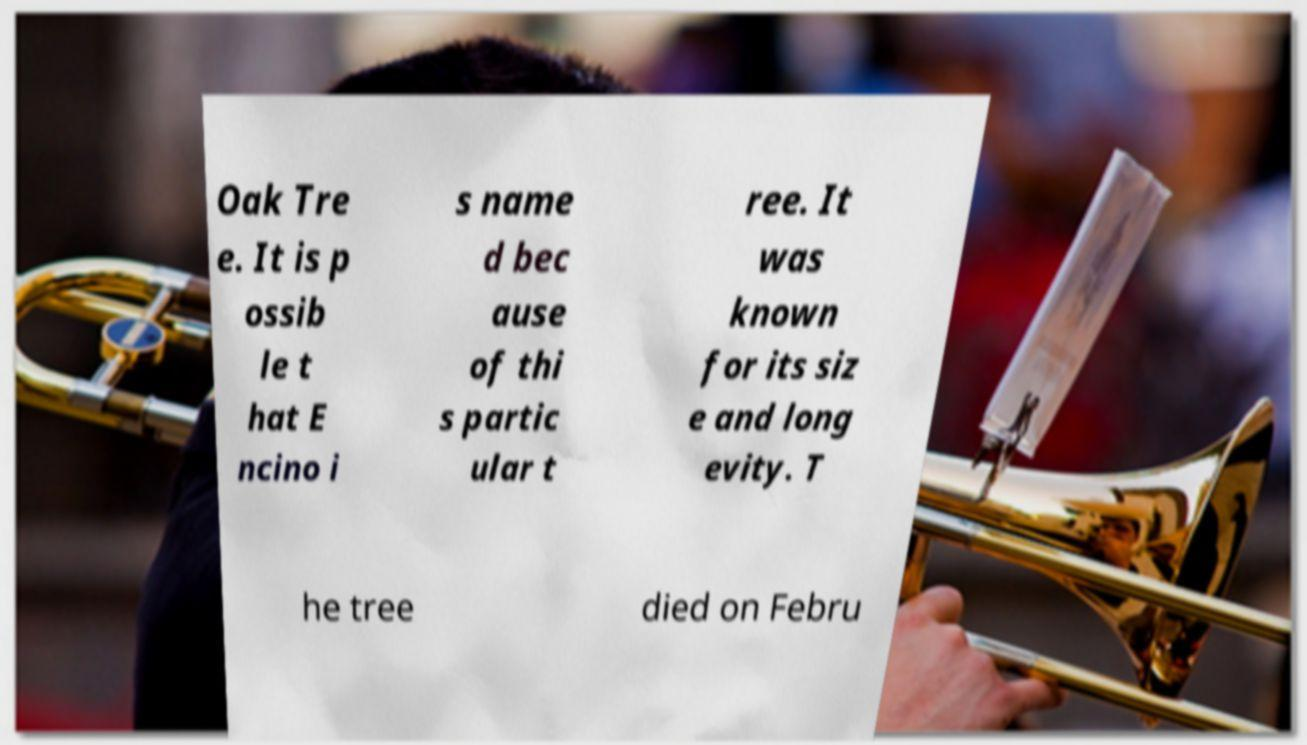Can you accurately transcribe the text from the provided image for me? Oak Tre e. It is p ossib le t hat E ncino i s name d bec ause of thi s partic ular t ree. It was known for its siz e and long evity. T he tree died on Febru 